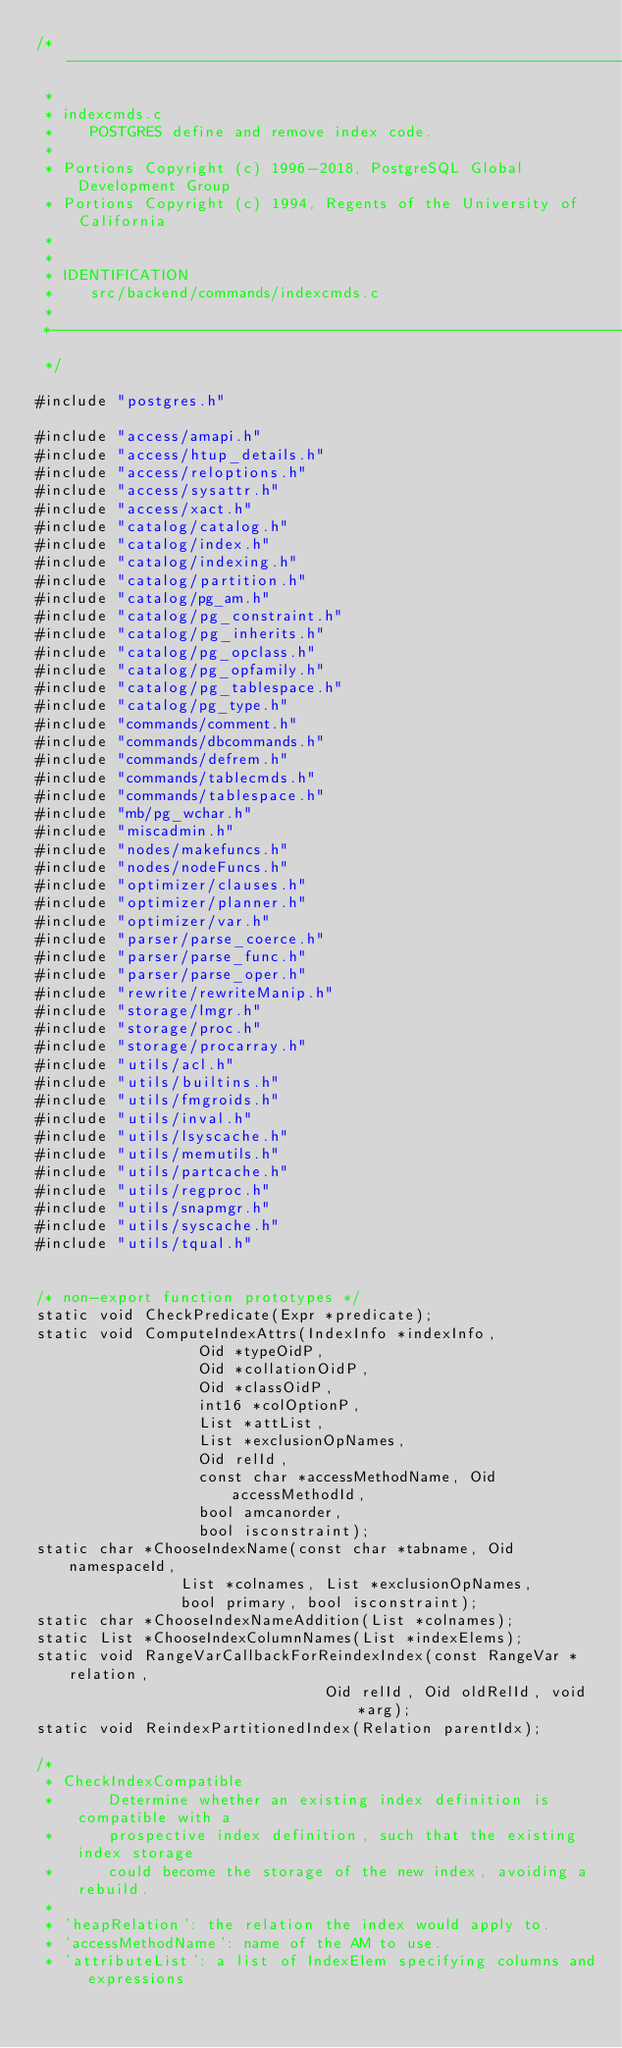<code> <loc_0><loc_0><loc_500><loc_500><_C_>/*-------------------------------------------------------------------------
 *
 * indexcmds.c
 *	  POSTGRES define and remove index code.
 *
 * Portions Copyright (c) 1996-2018, PostgreSQL Global Development Group
 * Portions Copyright (c) 1994, Regents of the University of California
 *
 *
 * IDENTIFICATION
 *	  src/backend/commands/indexcmds.c
 *
 *-------------------------------------------------------------------------
 */

#include "postgres.h"

#include "access/amapi.h"
#include "access/htup_details.h"
#include "access/reloptions.h"
#include "access/sysattr.h"
#include "access/xact.h"
#include "catalog/catalog.h"
#include "catalog/index.h"
#include "catalog/indexing.h"
#include "catalog/partition.h"
#include "catalog/pg_am.h"
#include "catalog/pg_constraint.h"
#include "catalog/pg_inherits.h"
#include "catalog/pg_opclass.h"
#include "catalog/pg_opfamily.h"
#include "catalog/pg_tablespace.h"
#include "catalog/pg_type.h"
#include "commands/comment.h"
#include "commands/dbcommands.h"
#include "commands/defrem.h"
#include "commands/tablecmds.h"
#include "commands/tablespace.h"
#include "mb/pg_wchar.h"
#include "miscadmin.h"
#include "nodes/makefuncs.h"
#include "nodes/nodeFuncs.h"
#include "optimizer/clauses.h"
#include "optimizer/planner.h"
#include "optimizer/var.h"
#include "parser/parse_coerce.h"
#include "parser/parse_func.h"
#include "parser/parse_oper.h"
#include "rewrite/rewriteManip.h"
#include "storage/lmgr.h"
#include "storage/proc.h"
#include "storage/procarray.h"
#include "utils/acl.h"
#include "utils/builtins.h"
#include "utils/fmgroids.h"
#include "utils/inval.h"
#include "utils/lsyscache.h"
#include "utils/memutils.h"
#include "utils/partcache.h"
#include "utils/regproc.h"
#include "utils/snapmgr.h"
#include "utils/syscache.h"
#include "utils/tqual.h"


/* non-export function prototypes */
static void CheckPredicate(Expr *predicate);
static void ComputeIndexAttrs(IndexInfo *indexInfo,
				  Oid *typeOidP,
				  Oid *collationOidP,
				  Oid *classOidP,
				  int16 *colOptionP,
				  List *attList,
				  List *exclusionOpNames,
				  Oid relId,
				  const char *accessMethodName, Oid accessMethodId,
				  bool amcanorder,
				  bool isconstraint);
static char *ChooseIndexName(const char *tabname, Oid namespaceId,
				List *colnames, List *exclusionOpNames,
				bool primary, bool isconstraint);
static char *ChooseIndexNameAddition(List *colnames);
static List *ChooseIndexColumnNames(List *indexElems);
static void RangeVarCallbackForReindexIndex(const RangeVar *relation,
								Oid relId, Oid oldRelId, void *arg);
static void ReindexPartitionedIndex(Relation parentIdx);

/*
 * CheckIndexCompatible
 *		Determine whether an existing index definition is compatible with a
 *		prospective index definition, such that the existing index storage
 *		could become the storage of the new index, avoiding a rebuild.
 *
 * 'heapRelation': the relation the index would apply to.
 * 'accessMethodName': name of the AM to use.
 * 'attributeList': a list of IndexElem specifying columns and expressions</code> 